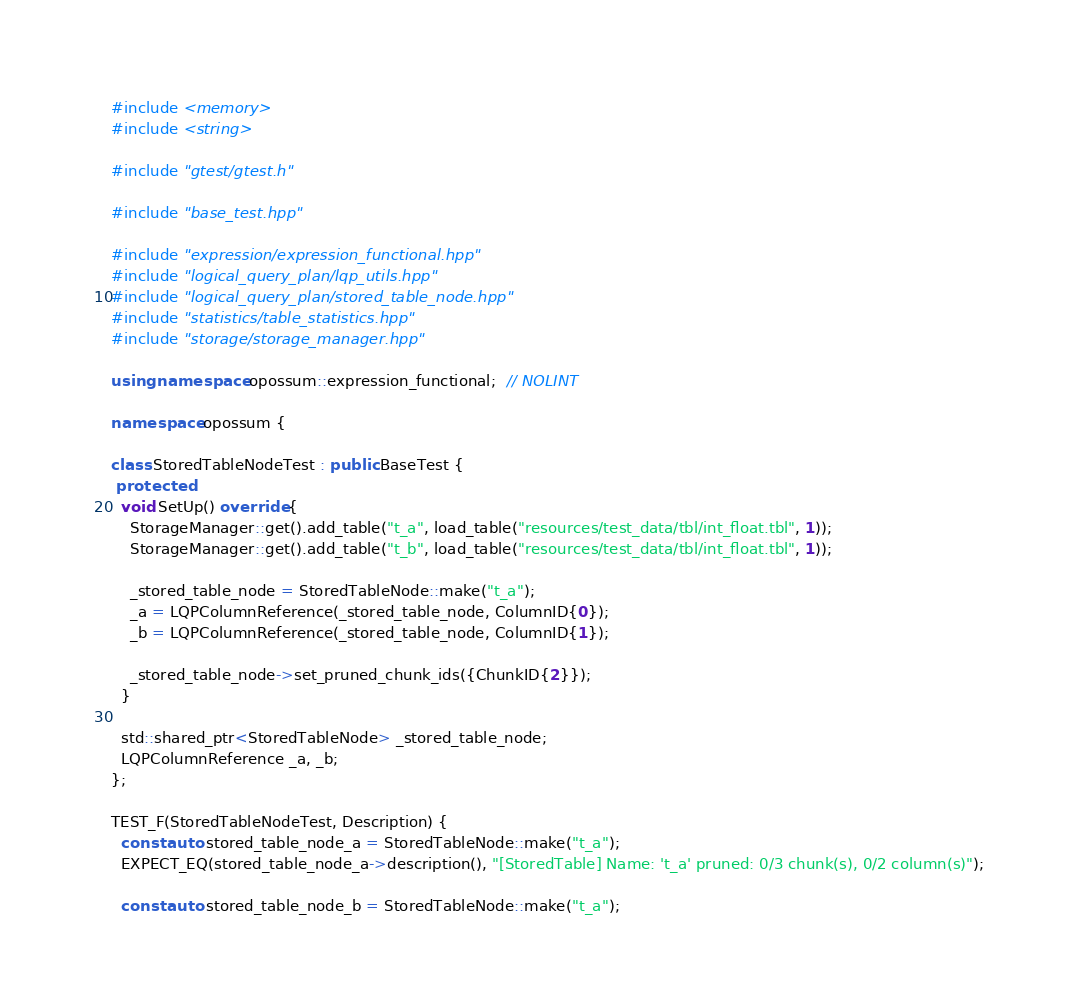<code> <loc_0><loc_0><loc_500><loc_500><_C++_>#include <memory>
#include <string>

#include "gtest/gtest.h"

#include "base_test.hpp"

#include "expression/expression_functional.hpp"
#include "logical_query_plan/lqp_utils.hpp"
#include "logical_query_plan/stored_table_node.hpp"
#include "statistics/table_statistics.hpp"
#include "storage/storage_manager.hpp"

using namespace opossum::expression_functional;  // NOLINT

namespace opossum {

class StoredTableNodeTest : public BaseTest {
 protected:
  void SetUp() override {
    StorageManager::get().add_table("t_a", load_table("resources/test_data/tbl/int_float.tbl", 1));
    StorageManager::get().add_table("t_b", load_table("resources/test_data/tbl/int_float.tbl", 1));

    _stored_table_node = StoredTableNode::make("t_a");
    _a = LQPColumnReference(_stored_table_node, ColumnID{0});
    _b = LQPColumnReference(_stored_table_node, ColumnID{1});

    _stored_table_node->set_pruned_chunk_ids({ChunkID{2}});
  }

  std::shared_ptr<StoredTableNode> _stored_table_node;
  LQPColumnReference _a, _b;
};

TEST_F(StoredTableNodeTest, Description) {
  const auto stored_table_node_a = StoredTableNode::make("t_a");
  EXPECT_EQ(stored_table_node_a->description(), "[StoredTable] Name: 't_a' pruned: 0/3 chunk(s), 0/2 column(s)");

  const auto stored_table_node_b = StoredTableNode::make("t_a");</code> 